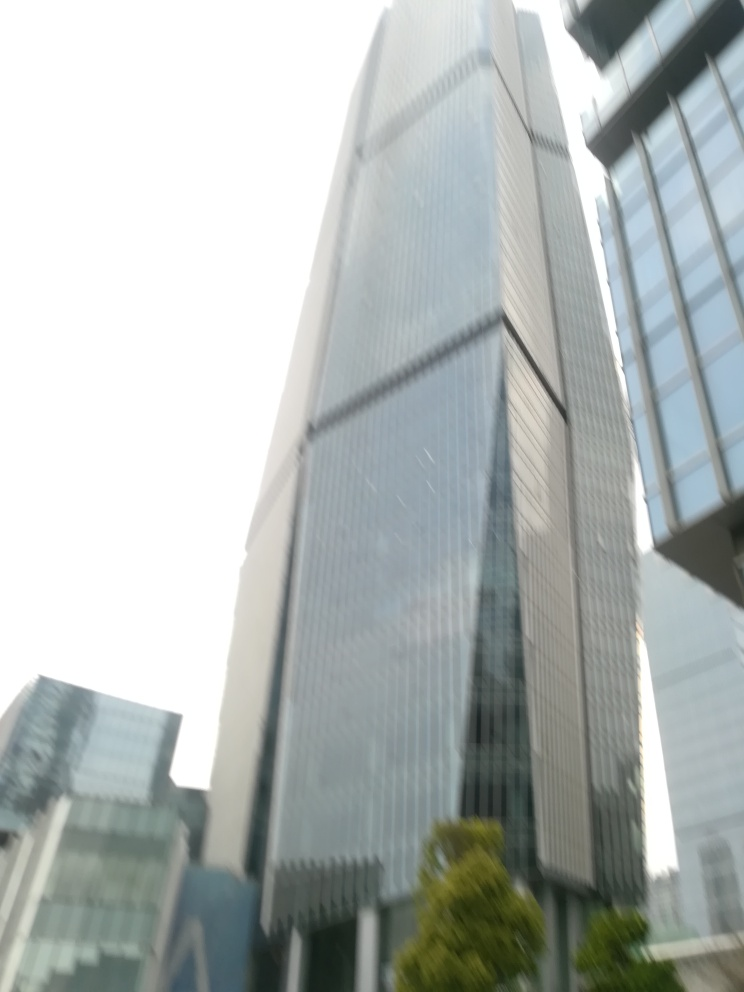Can you speculate on the purpose of this building? Given its tall stature, reflective glass surface, and urban location, it's likely that this building serves a commercial or corporate function, possibly housing offices for businesses or providing mixed-use spaces with retail and dining options on lower levels. 